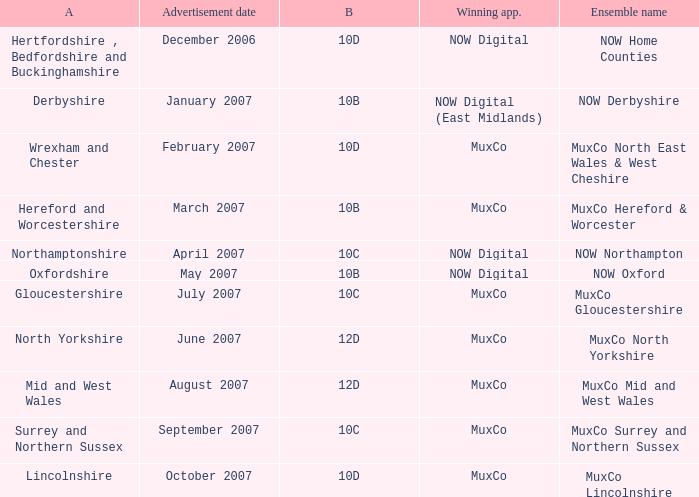Which Block does Northamptonshire Area have? 10C. 